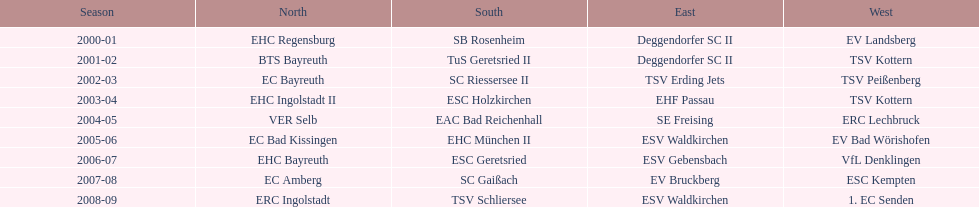Were there any appearances by ecs kempten before the 2007-08 season? No. 